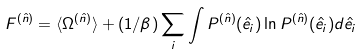Convert formula to latex. <formula><loc_0><loc_0><loc_500><loc_500>F ^ { ( \hat { n } ) } = \langle \Omega ^ { ( \hat { n } ) } \rangle + ( 1 / \beta ) \sum _ { i } \int P ^ { ( \hat { n } ) } ( \hat { e } _ { i } ) \ln P ^ { ( \hat { n } ) } ( \hat { e } _ { i } ) d \hat { e } _ { i }</formula> 